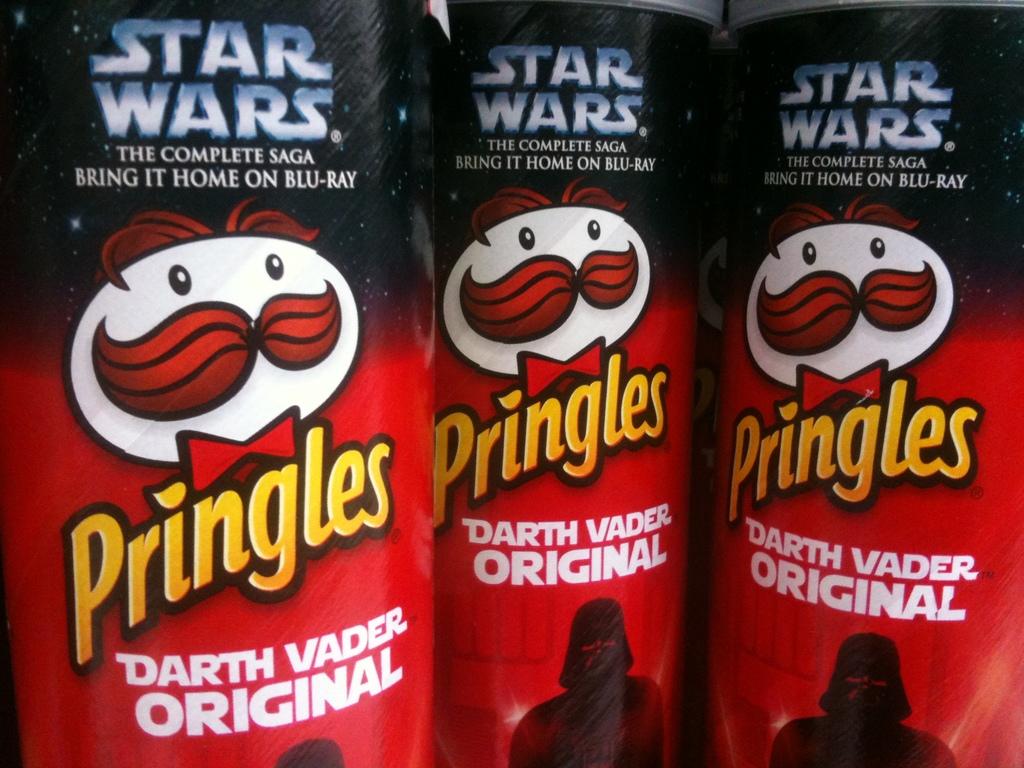What is this special pringles flavor called?
Your response must be concise. Darth vader original. 